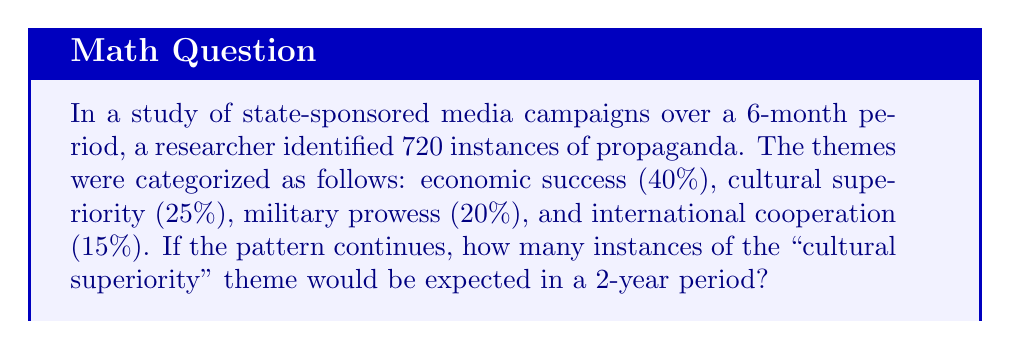What is the answer to this math problem? Let's break this down step-by-step:

1) First, we need to calculate how many instances of the "cultural superiority" theme occurred in the 6-month period:
   
   $25\% \text{ of } 720 = 0.25 \times 720 = 180$ instances

2) Now, we need to extrapolate this to a 2-year period. There are four 6-month periods in 2 years, so we multiply by 4:
   
   $180 \times 4 = 720$ instances

3) However, we need to be cautious about this linear extrapolation. The question states "If the pattern continues," which is a big assumption. In reality, propaganda themes and frequencies often shift over time based on political needs and global events.

4) The formula for this calculation can be expressed as:

   $$T = I \times P \times F$$

   Where:
   $T$ = Total instances over the longer period
   $I$ = Initial instances in the base period
   $P$ = Percentage of the specific theme
   $F$ = Factor of time increase

5) In this case:
   $I = 720$
   $P = 0.25$
   $F = 4$

   So: $T = 720 \times 0.25 \times 4 = 720$

This linear projection assumes consistency in both the total volume of propaganda and the proportion of themes, which may not reflect real-world dynamics of state media manipulation.
Answer: 720 instances 